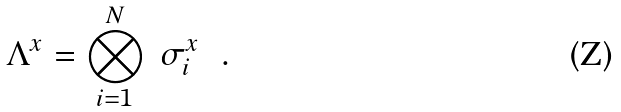<formula> <loc_0><loc_0><loc_500><loc_500>\Lambda ^ { x } = \bigotimes ^ { N } _ { i = 1 } \ \sigma ^ { x } _ { i } \ \ .</formula> 